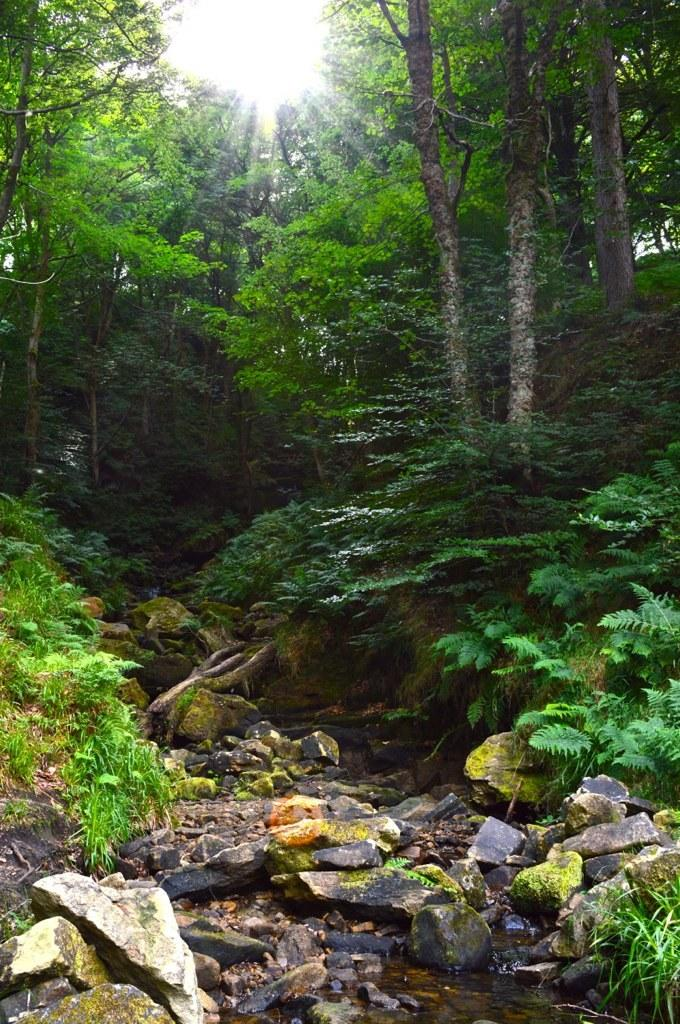What type of vegetation is present in the image? There are trees in the image. What other natural elements can be seen in the image? There are stones and grass visible in the image. Is there any water present in the image? Yes, there is water in the image. What is the color of the sky in the image? The sky appears to be white in color. How many fingers can be seen pointing at the trees in the image? There are no fingers visible in the image; it features trees, stones, grass, water, and a white sky. What is the head of the person doing in the image? There is no person or head present in the image. 